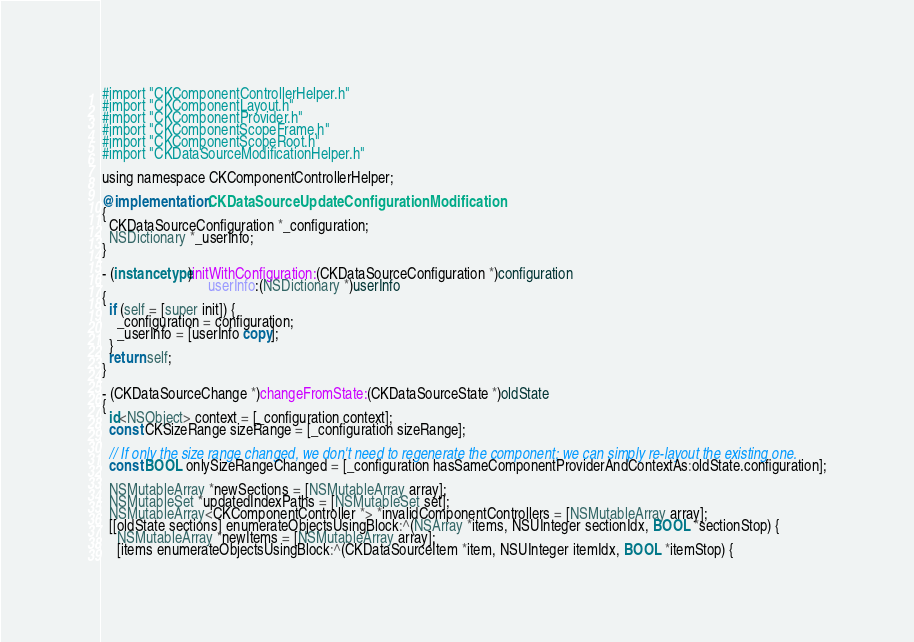Convert code to text. <code><loc_0><loc_0><loc_500><loc_500><_ObjectiveC_>#import "CKComponentControllerHelper.h"
#import "CKComponentLayout.h"
#import "CKComponentProvider.h"
#import "CKComponentScopeFrame.h"
#import "CKComponentScopeRoot.h"
#import "CKDataSourceModificationHelper.h"

using namespace CKComponentControllerHelper;

@implementation CKDataSourceUpdateConfigurationModification
{
  CKDataSourceConfiguration *_configuration;
  NSDictionary *_userInfo;
}

- (instancetype)initWithConfiguration:(CKDataSourceConfiguration *)configuration
                             userInfo:(NSDictionary *)userInfo
{
  if (self = [super init]) {
    _configuration = configuration;
    _userInfo = [userInfo copy];
  }
  return self;
}

- (CKDataSourceChange *)changeFromState:(CKDataSourceState *)oldState
{
  id<NSObject> context = [_configuration context];
  const CKSizeRange sizeRange = [_configuration sizeRange];

  // If only the size range changed, we don't need to regenerate the component; we can simply re-layout the existing one.
  const BOOL onlySizeRangeChanged = [_configuration hasSameComponentProviderAndContextAs:oldState.configuration];

  NSMutableArray *newSections = [NSMutableArray array];
  NSMutableSet *updatedIndexPaths = [NSMutableSet set];
  NSMutableArray<CKComponentController *> *invalidComponentControllers = [NSMutableArray array];
  [[oldState sections] enumerateObjectsUsingBlock:^(NSArray *items, NSUInteger sectionIdx, BOOL *sectionStop) {
    NSMutableArray *newItems = [NSMutableArray array];
    [items enumerateObjectsUsingBlock:^(CKDataSourceItem *item, NSUInteger itemIdx, BOOL *itemStop) {</code> 